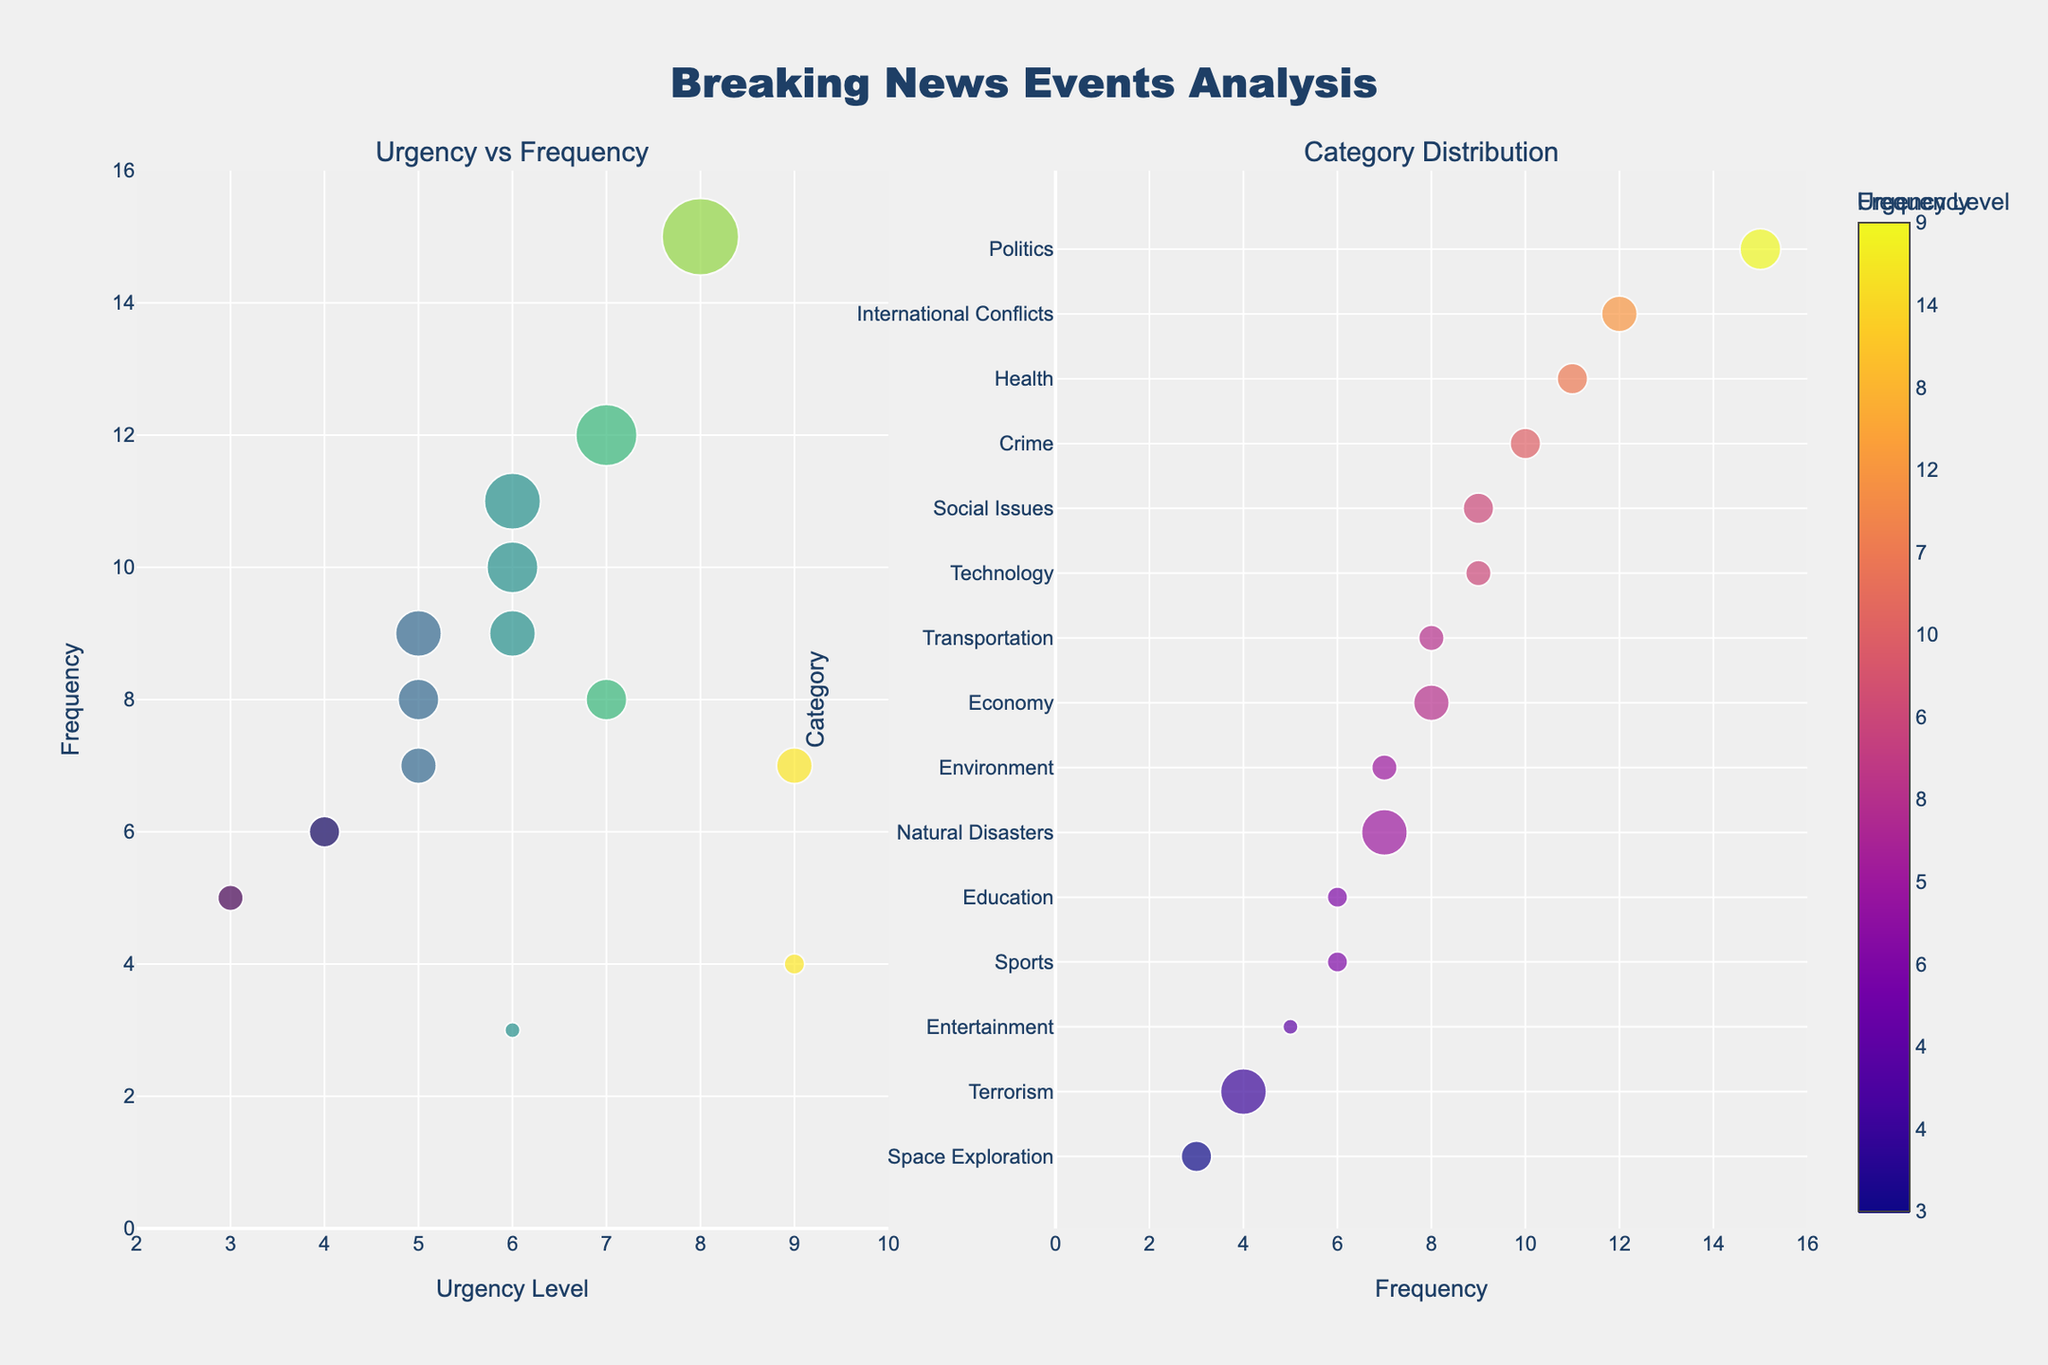What's the title of the figure? The title is prominently placed at the top center of the figure. It reads "Breaking News Events Analysis" in bold Arial Black font.
Answer: Breaking News Events Analysis Which category has the highest urgency level? The scatter plot on the left shows urgency levels on the x-axis. The category with the highest value on the x-axis (urgency level 9) is "Natural Disasters."
Answer: Natural Disasters How many categories have a frequency of 10 or greater? By observing the y-axis on the scatter plot on the left and the x-axis on the scatter plot on the right, count the categories that have a y-value of 10 or greater. The categories are Politics, International Conflicts, and Crime.
Answer: Three categories What is the frequency range for the "Technology" category? On the scatter plot on the right, find the "Technology" category on the y-axis and check its corresponding x-value. The "Technology" category has an x-value (frequency) of 9.
Answer: 9 Compare the urgency levels of "Health" and "Economy." Which one is higher? Locate both "Health" and "Economy" categories on the scatter plot (left side), using the x-axis (urgency level). "Health" has an urgency level of 6, while "Economy" has an urgency level of 7.
Answer: Economy Which categories appear between 4 and 5 on the urgency level scale? Find the x-values between 4 and 5 on the scatter plot on the left and identify the corresponding categories. These categories are "Transport" and "Environment."
Answer: Transport and Environment What is the most frequent category? On the right scatter plot, the x-axis represents frequency. The category with the highest x-value (15) is "Politics."
Answer: Politics How does the size of the markers correlate with urgency and frequency? In both scatter plots, marker size increases with the values of urgency levels (left plot) and frequency (right plot). This scaling makes markers representing higher urgency and frequency larger.
Answer: Larger markers indicate higher urgency and frequency What's the relationship between the urgency and frequency of "Sports"? In the scatter plot on the left, "Sports" has an urgency of 4 and a frequency of 6. This can be cross-verified in the right scatter plot where "Sports" has a frequency of 6.
Answer: Urgency: 4, Frequency: 6 